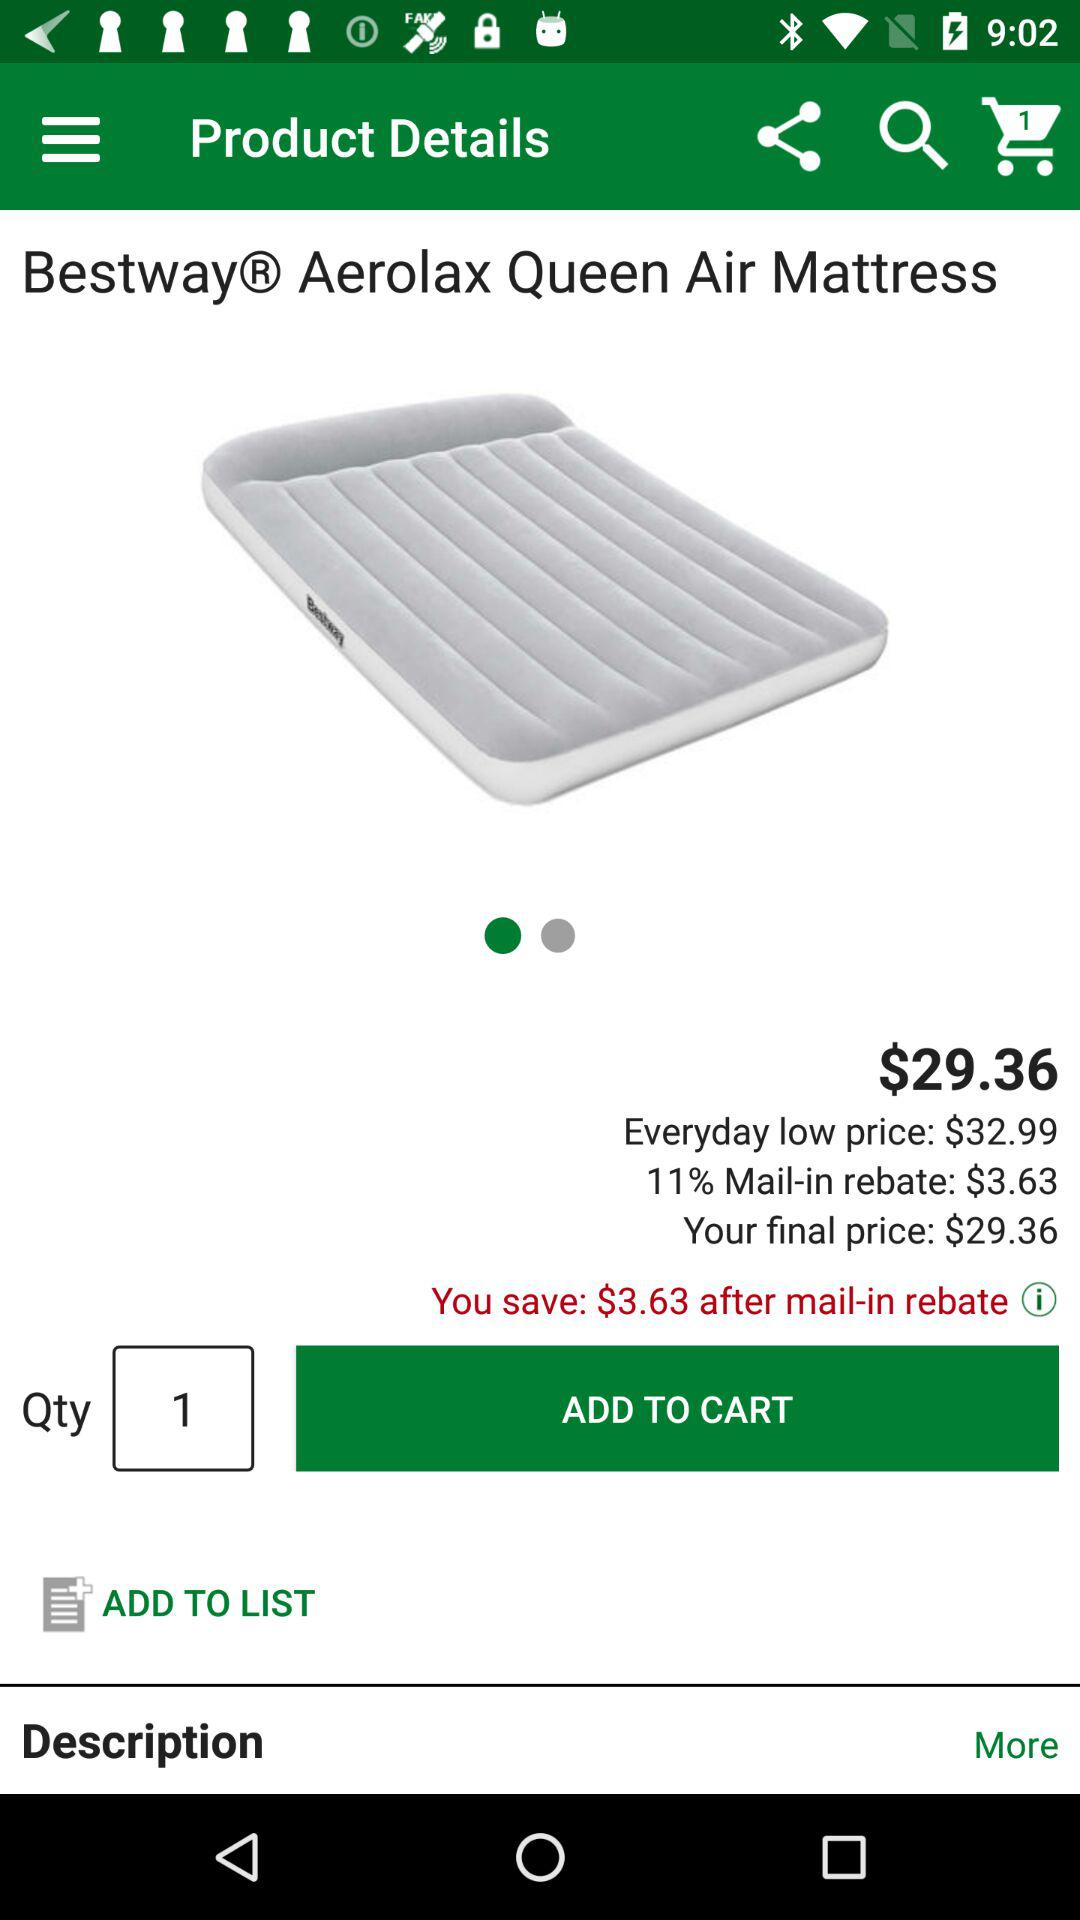How many quantities of the product were selected? The selected quantity of the product was 1. 